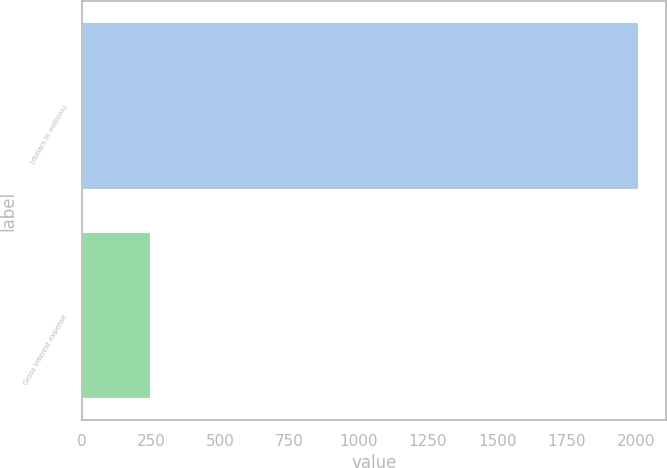Convert chart to OTSL. <chart><loc_0><loc_0><loc_500><loc_500><bar_chart><fcel>(dollars in millions)<fcel>Gross interest expense<nl><fcel>2010<fcel>250<nl></chart> 